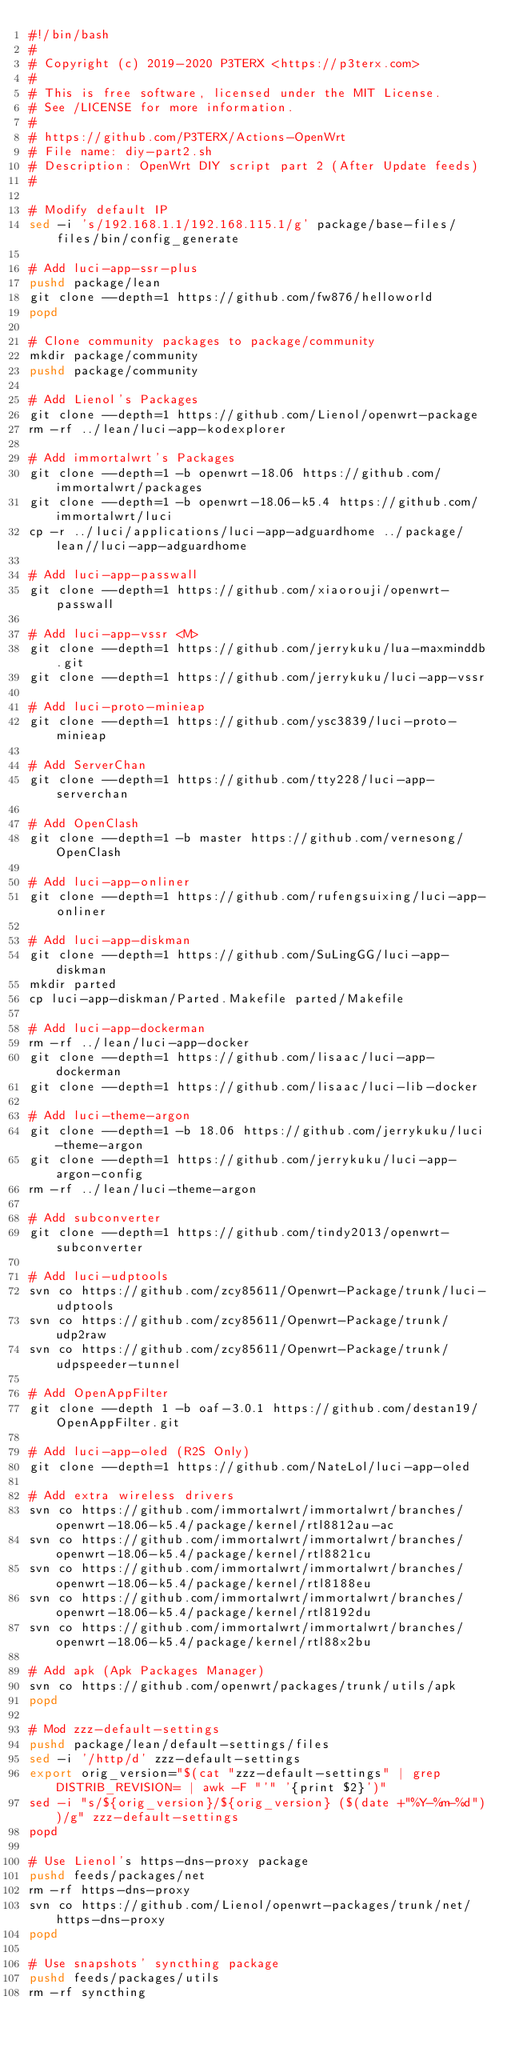Convert code to text. <code><loc_0><loc_0><loc_500><loc_500><_Bash_>#!/bin/bash
#
# Copyright (c) 2019-2020 P3TERX <https://p3terx.com>
#
# This is free software, licensed under the MIT License.
# See /LICENSE for more information.
#
# https://github.com/P3TERX/Actions-OpenWrt
# File name: diy-part2.sh
# Description: OpenWrt DIY script part 2 (After Update feeds)
#

# Modify default IP
sed -i 's/192.168.1.1/192.168.115.1/g' package/base-files/files/bin/config_generate

# Add luci-app-ssr-plus
pushd package/lean
git clone --depth=1 https://github.com/fw876/helloworld
popd

# Clone community packages to package/community
mkdir package/community
pushd package/community

# Add Lienol's Packages
git clone --depth=1 https://github.com/Lienol/openwrt-package
rm -rf ../lean/luci-app-kodexplorer

# Add immortalwrt's Packages
git clone --depth=1 -b openwrt-18.06 https://github.com/immortalwrt/packages
git clone --depth=1 -b openwrt-18.06-k5.4 https://github.com/immortalwrt/luci
cp -r ../luci/applications/luci-app-adguardhome ../package/lean//luci-app-adguardhome

# Add luci-app-passwall
git clone --depth=1 https://github.com/xiaorouji/openwrt-passwall

# Add luci-app-vssr <M>
git clone --depth=1 https://github.com/jerrykuku/lua-maxminddb.git
git clone --depth=1 https://github.com/jerrykuku/luci-app-vssr

# Add luci-proto-minieap
git clone --depth=1 https://github.com/ysc3839/luci-proto-minieap

# Add ServerChan
git clone --depth=1 https://github.com/tty228/luci-app-serverchan

# Add OpenClash
git clone --depth=1 -b master https://github.com/vernesong/OpenClash

# Add luci-app-onliner
git clone --depth=1 https://github.com/rufengsuixing/luci-app-onliner

# Add luci-app-diskman
git clone --depth=1 https://github.com/SuLingGG/luci-app-diskman
mkdir parted
cp luci-app-diskman/Parted.Makefile parted/Makefile

# Add luci-app-dockerman
rm -rf ../lean/luci-app-docker
git clone --depth=1 https://github.com/lisaac/luci-app-dockerman
git clone --depth=1 https://github.com/lisaac/luci-lib-docker

# Add luci-theme-argon
git clone --depth=1 -b 18.06 https://github.com/jerrykuku/luci-theme-argon
git clone --depth=1 https://github.com/jerrykuku/luci-app-argon-config
rm -rf ../lean/luci-theme-argon

# Add subconverter
git clone --depth=1 https://github.com/tindy2013/openwrt-subconverter

# Add luci-udptools
svn co https://github.com/zcy85611/Openwrt-Package/trunk/luci-udptools
svn co https://github.com/zcy85611/Openwrt-Package/trunk/udp2raw
svn co https://github.com/zcy85611/Openwrt-Package/trunk/udpspeeder-tunnel

# Add OpenAppFilter
git clone --depth 1 -b oaf-3.0.1 https://github.com/destan19/OpenAppFilter.git

# Add luci-app-oled (R2S Only)
git clone --depth=1 https://github.com/NateLol/luci-app-oled

# Add extra wireless drivers
svn co https://github.com/immortalwrt/immortalwrt/branches/openwrt-18.06-k5.4/package/kernel/rtl8812au-ac
svn co https://github.com/immortalwrt/immortalwrt/branches/openwrt-18.06-k5.4/package/kernel/rtl8821cu
svn co https://github.com/immortalwrt/immortalwrt/branches/openwrt-18.06-k5.4/package/kernel/rtl8188eu
svn co https://github.com/immortalwrt/immortalwrt/branches/openwrt-18.06-k5.4/package/kernel/rtl8192du
svn co https://github.com/immortalwrt/immortalwrt/branches/openwrt-18.06-k5.4/package/kernel/rtl88x2bu

# Add apk (Apk Packages Manager)
svn co https://github.com/openwrt/packages/trunk/utils/apk
popd

# Mod zzz-default-settings
pushd package/lean/default-settings/files
sed -i '/http/d' zzz-default-settings
export orig_version="$(cat "zzz-default-settings" | grep DISTRIB_REVISION= | awk -F "'" '{print $2}')"
sed -i "s/${orig_version}/${orig_version} ($(date +"%Y-%m-%d"))/g" zzz-default-settings
popd

# Use Lienol's https-dns-proxy package
pushd feeds/packages/net
rm -rf https-dns-proxy
svn co https://github.com/Lienol/openwrt-packages/trunk/net/https-dns-proxy
popd

# Use snapshots' syncthing package
pushd feeds/packages/utils
rm -rf syncthing</code> 